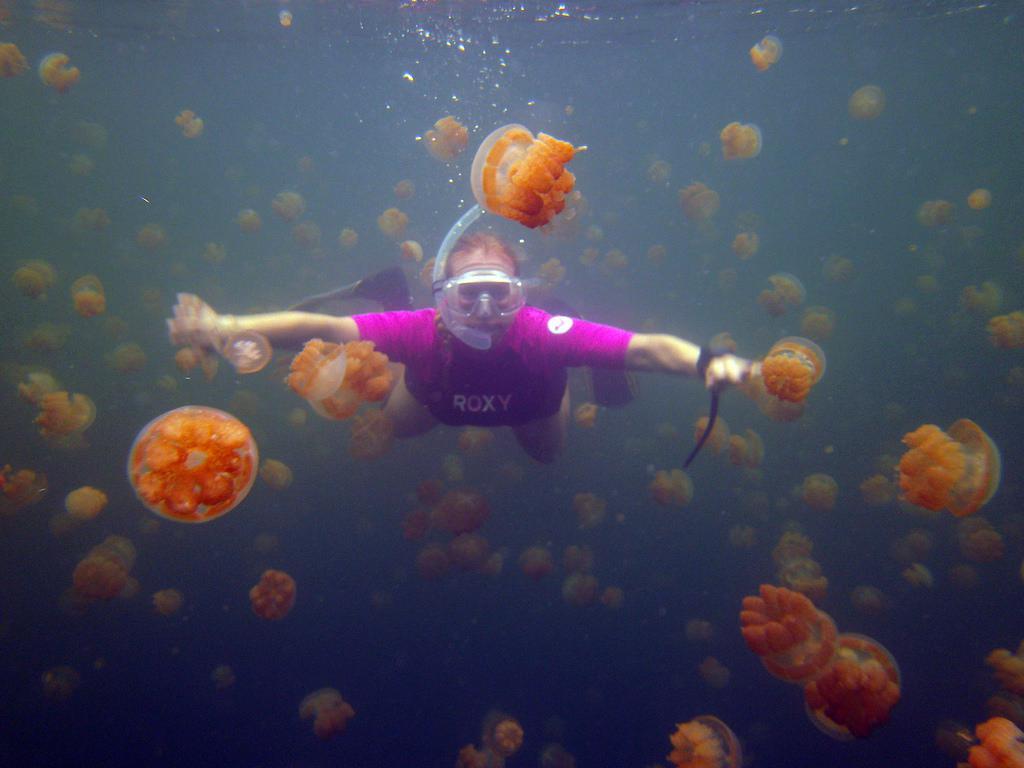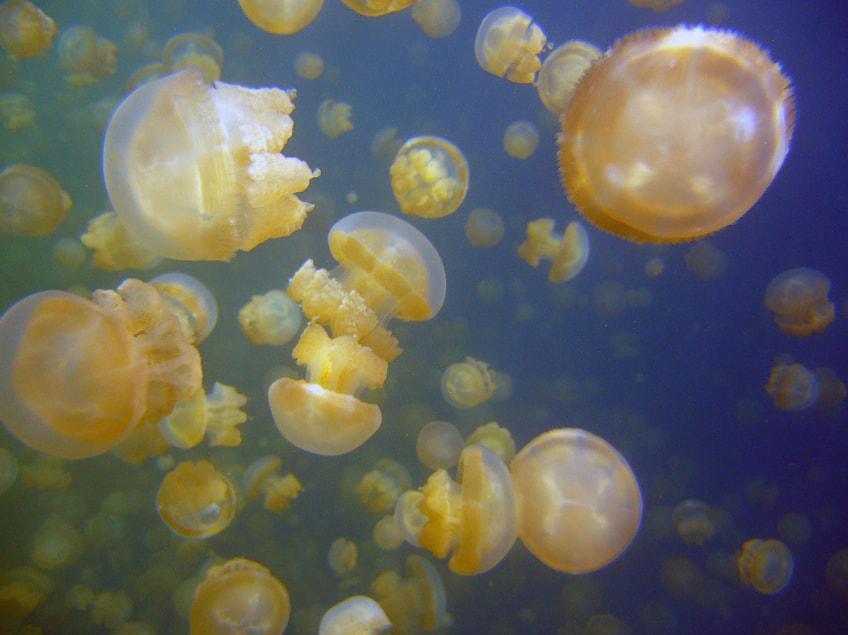The first image is the image on the left, the second image is the image on the right. Analyze the images presented: Is the assertion "A person is in one of the pictures." valid? Answer yes or no. Yes. The first image is the image on the left, the second image is the image on the right. Considering the images on both sides, is "An image shows a human present with jellyfish." valid? Answer yes or no. Yes. 